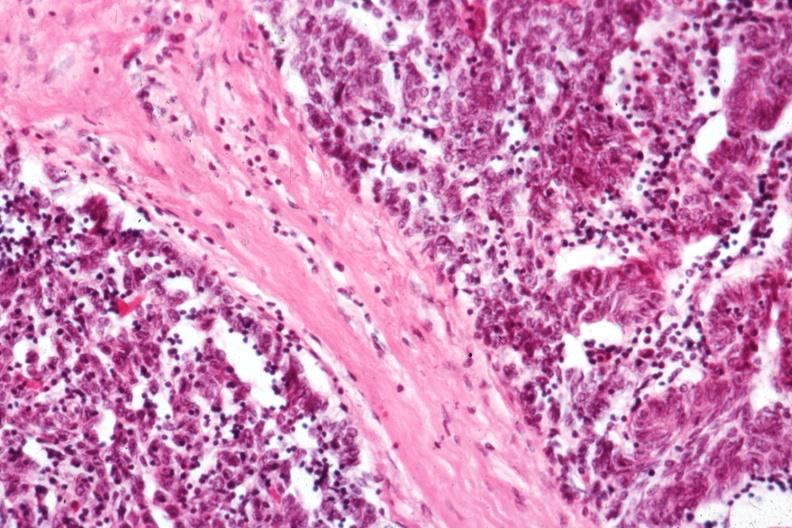does this image show predominant epithelial component?
Answer the question using a single word or phrase. Yes 